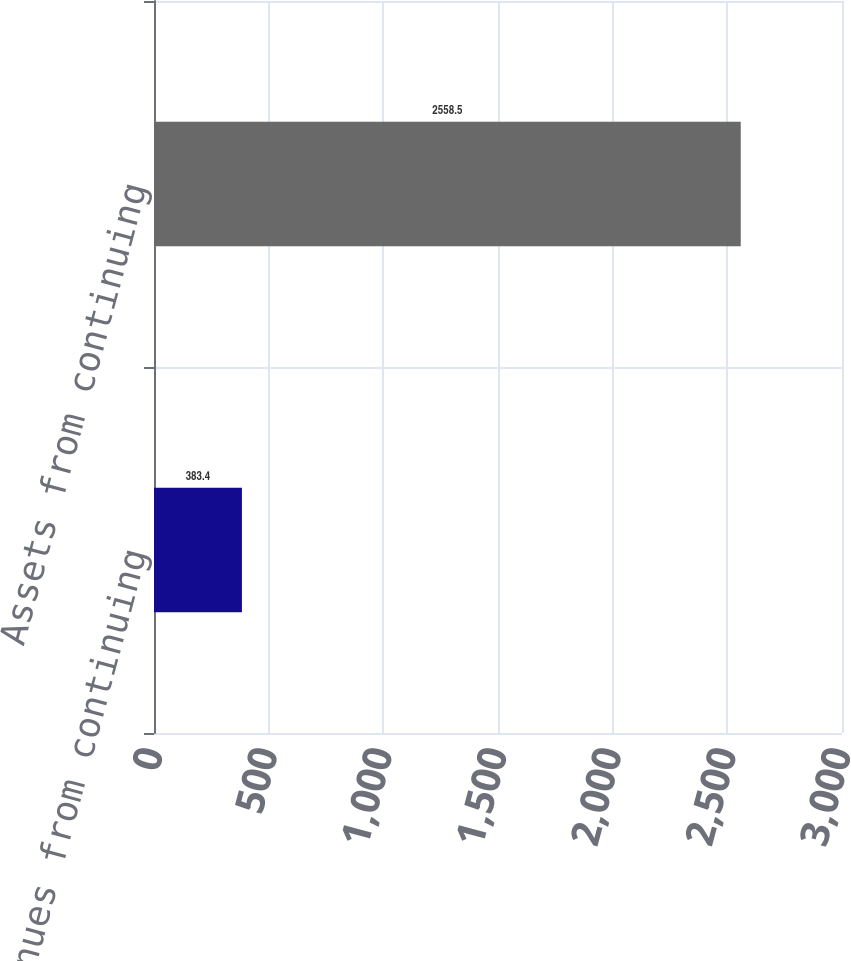Convert chart. <chart><loc_0><loc_0><loc_500><loc_500><bar_chart><fcel>Revenues from continuing<fcel>Assets from continuing<nl><fcel>383.4<fcel>2558.5<nl></chart> 